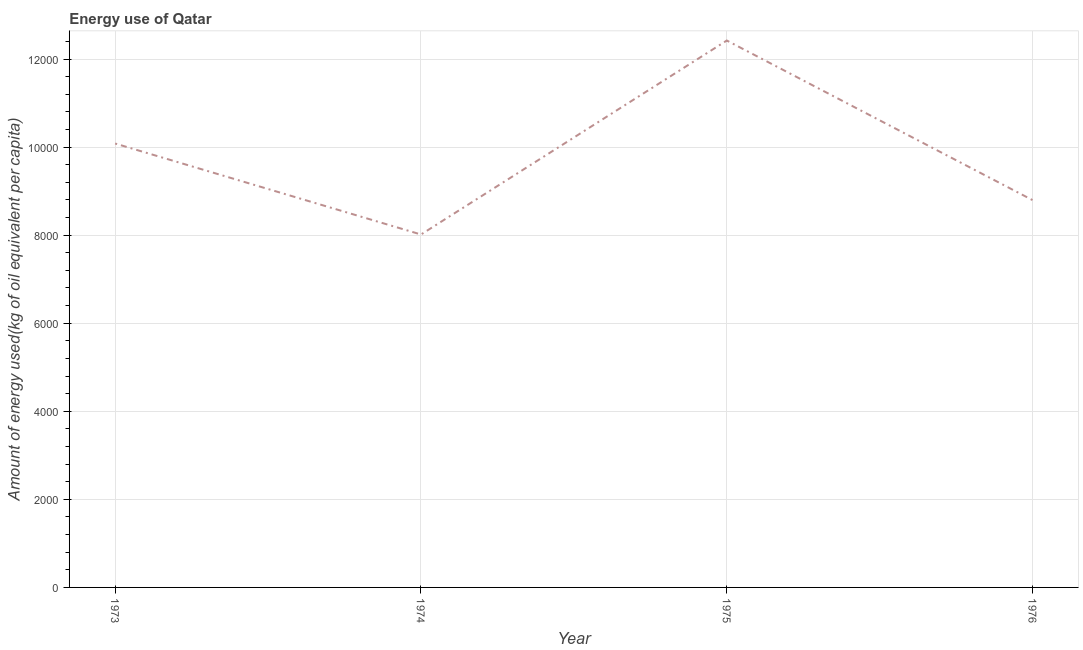What is the amount of energy used in 1975?
Keep it short and to the point. 1.24e+04. Across all years, what is the maximum amount of energy used?
Provide a short and direct response. 1.24e+04. Across all years, what is the minimum amount of energy used?
Make the answer very short. 8014.62. In which year was the amount of energy used maximum?
Ensure brevity in your answer.  1975. In which year was the amount of energy used minimum?
Your response must be concise. 1974. What is the sum of the amount of energy used?
Keep it short and to the point. 3.93e+04. What is the difference between the amount of energy used in 1974 and 1975?
Your response must be concise. -4405.15. What is the average amount of energy used per year?
Your answer should be very brief. 9827.46. What is the median amount of energy used?
Offer a terse response. 9437.72. What is the ratio of the amount of energy used in 1973 to that in 1975?
Provide a succinct answer. 0.81. Is the amount of energy used in 1974 less than that in 1975?
Make the answer very short. Yes. Is the difference between the amount of energy used in 1975 and 1976 greater than the difference between any two years?
Your answer should be very brief. No. What is the difference between the highest and the second highest amount of energy used?
Keep it short and to the point. 2339.11. Is the sum of the amount of energy used in 1973 and 1975 greater than the maximum amount of energy used across all years?
Give a very brief answer. Yes. What is the difference between the highest and the lowest amount of energy used?
Keep it short and to the point. 4405.15. Does the amount of energy used monotonically increase over the years?
Keep it short and to the point. No. How many lines are there?
Offer a very short reply. 1. How many years are there in the graph?
Ensure brevity in your answer.  4. Are the values on the major ticks of Y-axis written in scientific E-notation?
Ensure brevity in your answer.  No. Does the graph contain grids?
Make the answer very short. Yes. What is the title of the graph?
Your response must be concise. Energy use of Qatar. What is the label or title of the Y-axis?
Your response must be concise. Amount of energy used(kg of oil equivalent per capita). What is the Amount of energy used(kg of oil equivalent per capita) in 1973?
Offer a terse response. 1.01e+04. What is the Amount of energy used(kg of oil equivalent per capita) of 1974?
Ensure brevity in your answer.  8014.62. What is the Amount of energy used(kg of oil equivalent per capita) of 1975?
Your answer should be compact. 1.24e+04. What is the Amount of energy used(kg of oil equivalent per capita) in 1976?
Give a very brief answer. 8794.78. What is the difference between the Amount of energy used(kg of oil equivalent per capita) in 1973 and 1974?
Ensure brevity in your answer.  2066.03. What is the difference between the Amount of energy used(kg of oil equivalent per capita) in 1973 and 1975?
Provide a short and direct response. -2339.11. What is the difference between the Amount of energy used(kg of oil equivalent per capita) in 1973 and 1976?
Your answer should be compact. 1285.88. What is the difference between the Amount of energy used(kg of oil equivalent per capita) in 1974 and 1975?
Give a very brief answer. -4405.15. What is the difference between the Amount of energy used(kg of oil equivalent per capita) in 1974 and 1976?
Provide a short and direct response. -780.16. What is the difference between the Amount of energy used(kg of oil equivalent per capita) in 1975 and 1976?
Your answer should be compact. 3624.99. What is the ratio of the Amount of energy used(kg of oil equivalent per capita) in 1973 to that in 1974?
Ensure brevity in your answer.  1.26. What is the ratio of the Amount of energy used(kg of oil equivalent per capita) in 1973 to that in 1975?
Give a very brief answer. 0.81. What is the ratio of the Amount of energy used(kg of oil equivalent per capita) in 1973 to that in 1976?
Make the answer very short. 1.15. What is the ratio of the Amount of energy used(kg of oil equivalent per capita) in 1974 to that in 1975?
Your answer should be very brief. 0.65. What is the ratio of the Amount of energy used(kg of oil equivalent per capita) in 1974 to that in 1976?
Provide a succinct answer. 0.91. What is the ratio of the Amount of energy used(kg of oil equivalent per capita) in 1975 to that in 1976?
Your answer should be compact. 1.41. 